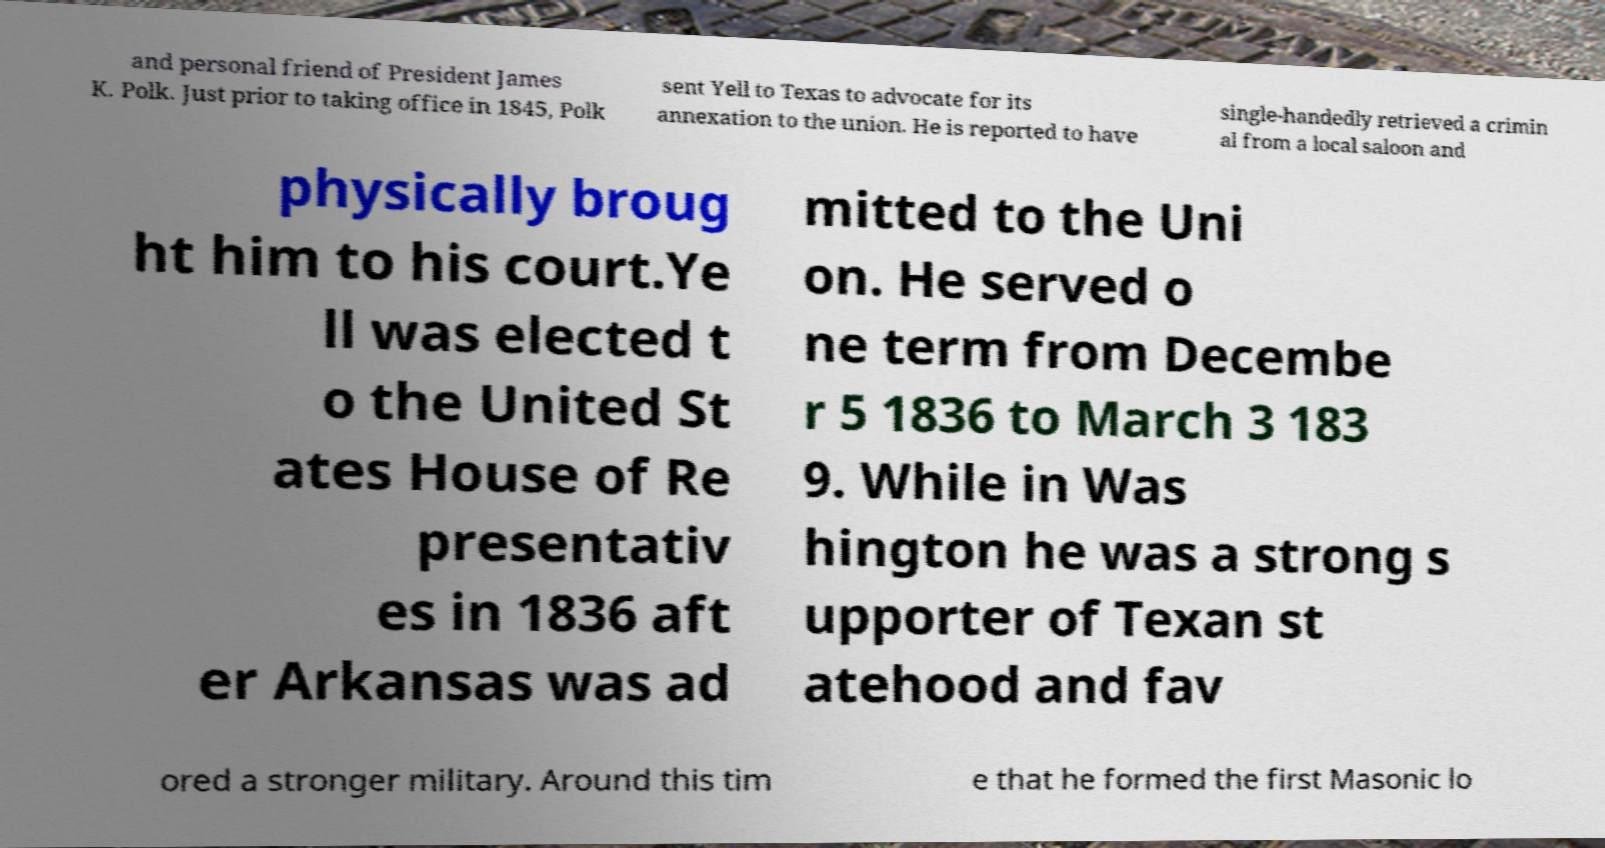Can you accurately transcribe the text from the provided image for me? and personal friend of President James K. Polk. Just prior to taking office in 1845, Polk sent Yell to Texas to advocate for its annexation to the union. He is reported to have single-handedly retrieved a crimin al from a local saloon and physically broug ht him to his court.Ye ll was elected t o the United St ates House of Re presentativ es in 1836 aft er Arkansas was ad mitted to the Uni on. He served o ne term from Decembe r 5 1836 to March 3 183 9. While in Was hington he was a strong s upporter of Texan st atehood and fav ored a stronger military. Around this tim e that he formed the first Masonic lo 